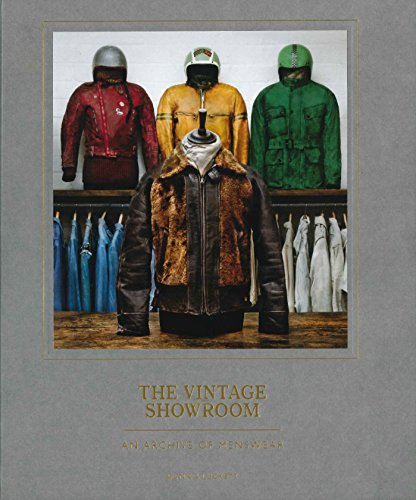Can you describe the styles of jackets shown on the cover of the book? The cover features a variety of vintage jackets including a leather biker jacket, a racing jacket, a bomber jacket, and other distinctive styles. Each represents a different era and subculture, capturing the essence of classic menswear. 